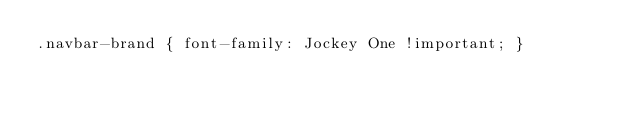<code> <loc_0><loc_0><loc_500><loc_500><_CSS_>.navbar-brand { font-family: Jockey One !important; }</code> 